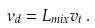Convert formula to latex. <formula><loc_0><loc_0><loc_500><loc_500>\nu _ { d } = L _ { m i x } v _ { t } \, .</formula> 